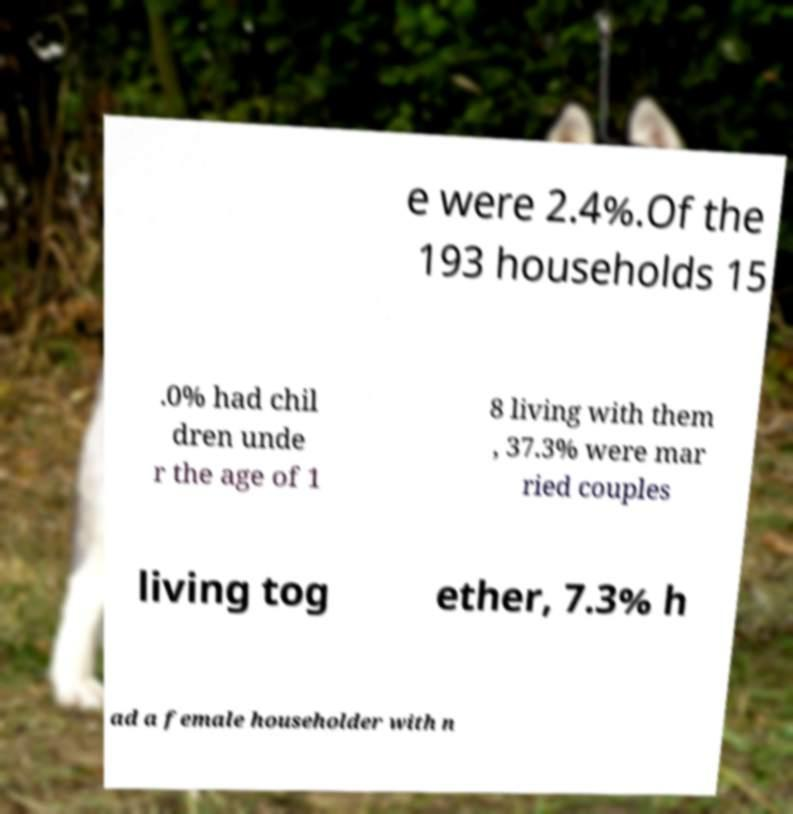Please read and relay the text visible in this image. What does it say? e were 2.4%.Of the 193 households 15 .0% had chil dren unde r the age of 1 8 living with them , 37.3% were mar ried couples living tog ether, 7.3% h ad a female householder with n 